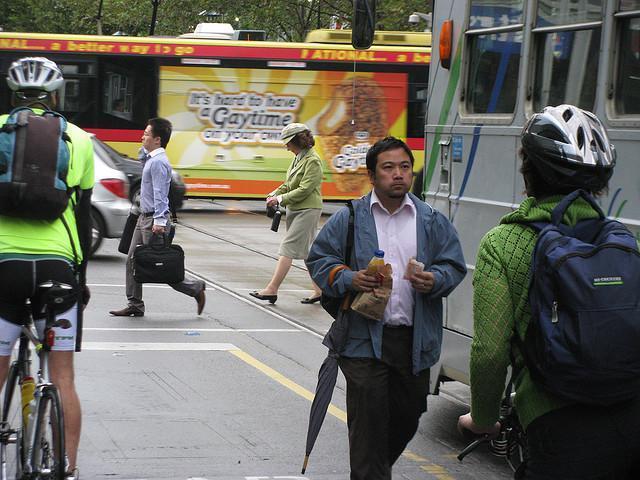How many people are in the photo?
Give a very brief answer. 5. How many bicycles are in the picture?
Give a very brief answer. 2. How many umbrellas are in this picture?
Give a very brief answer. 1. How many people can be seen?
Give a very brief answer. 5. How many backpacks are there?
Give a very brief answer. 2. How many buses are in the photo?
Give a very brief answer. 2. How many baby elephants are there?
Give a very brief answer. 0. 